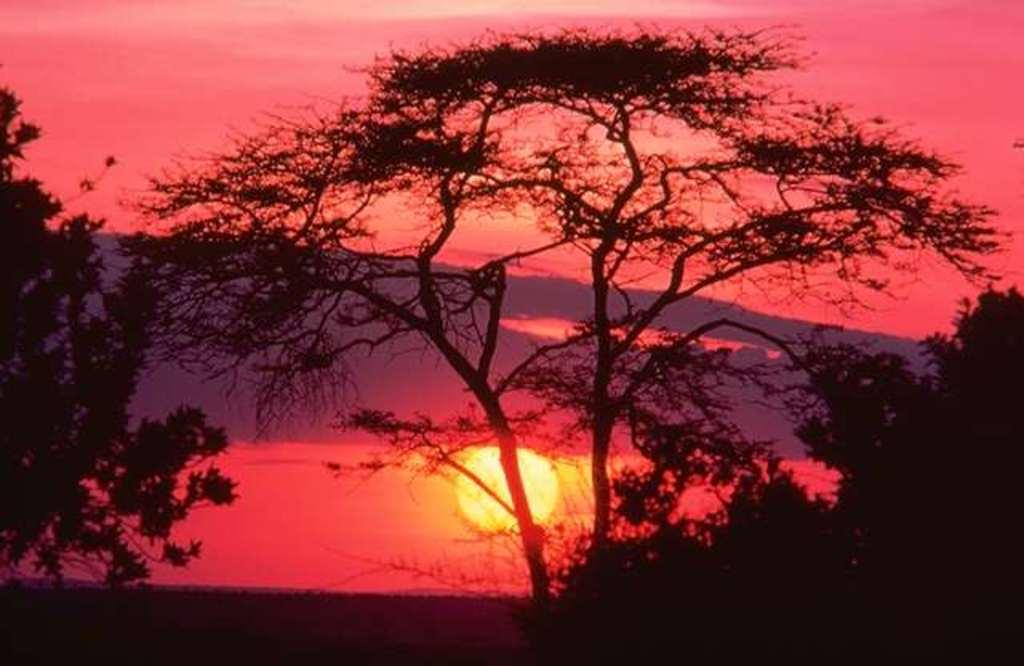What celestial body is visible in the image? The sun is visible in the image. What is the color of the sky in the image? The sky appears red in the image. What type of vegetation can be seen in the image? There are trees in the image. How many dinosaurs can be seen grazing in the field in the image? There are no dinosaurs present in the image; it features the sun, a red sky, and trees. What type of bone is visible in the image? There is no bone present in the image. 